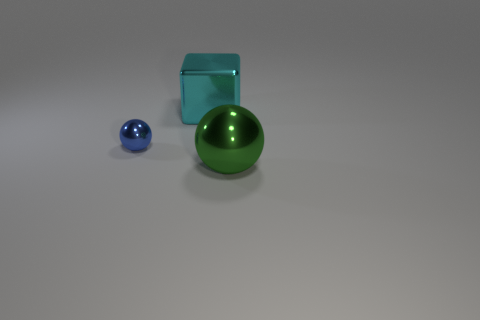How many matte things are either large cyan cubes or cyan spheres?
Provide a short and direct response. 0. Is there any other thing that is the same material as the tiny ball?
Your response must be concise. Yes. How big is the object in front of the metallic ball that is on the left side of the big shiny thing that is on the left side of the large green sphere?
Your answer should be compact. Large. There is a metal thing that is both in front of the big cyan block and on the left side of the green object; what is its size?
Your response must be concise. Small. There is a tiny shiny sphere; what number of small blue shiny spheres are left of it?
Offer a very short reply. 0. There is a metal ball that is to the right of the large thing that is behind the big ball; are there any small metal balls that are on the right side of it?
Give a very brief answer. No. How many green balls are the same size as the green metal thing?
Your answer should be compact. 0. What shape is the large object to the left of the big metallic thing that is in front of the large shiny object behind the big green sphere?
Offer a terse response. Cube. There is a thing that is left of the metallic block; does it have the same shape as the big metallic thing in front of the blue shiny thing?
Provide a succinct answer. Yes. What number of other objects are there of the same material as the blue object?
Your answer should be very brief. 2. 